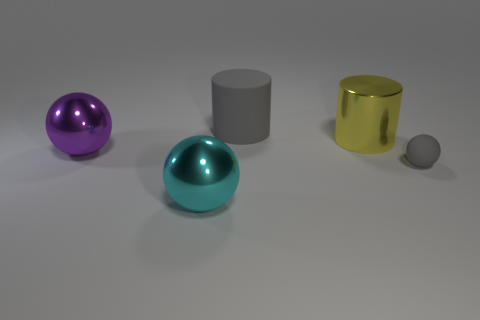Is there anything else that has the same size as the gray matte ball?
Your answer should be compact. No. There is a tiny sphere; is its color the same as the matte object to the left of the gray sphere?
Make the answer very short. Yes. There is a gray cylinder that is to the left of the matte ball; what number of purple things are to the left of it?
Your answer should be compact. 1. There is a metallic thing that is both in front of the big yellow cylinder and behind the large cyan thing; what size is it?
Offer a very short reply. Large. Are there any other things that have the same size as the purple object?
Your answer should be compact. Yes. Are there more large things on the left side of the yellow shiny thing than cyan spheres that are right of the big cyan object?
Provide a short and direct response. Yes. Is the yellow thing made of the same material as the large object that is in front of the small rubber object?
Make the answer very short. Yes. How many metallic objects are behind the sphere that is to the left of the metal ball that is in front of the gray rubber ball?
Your answer should be compact. 1. There is a cyan thing; is its shape the same as the thing behind the yellow shiny thing?
Your answer should be very brief. No. The large object that is both in front of the big gray object and to the right of the big cyan shiny thing is what color?
Give a very brief answer. Yellow. 